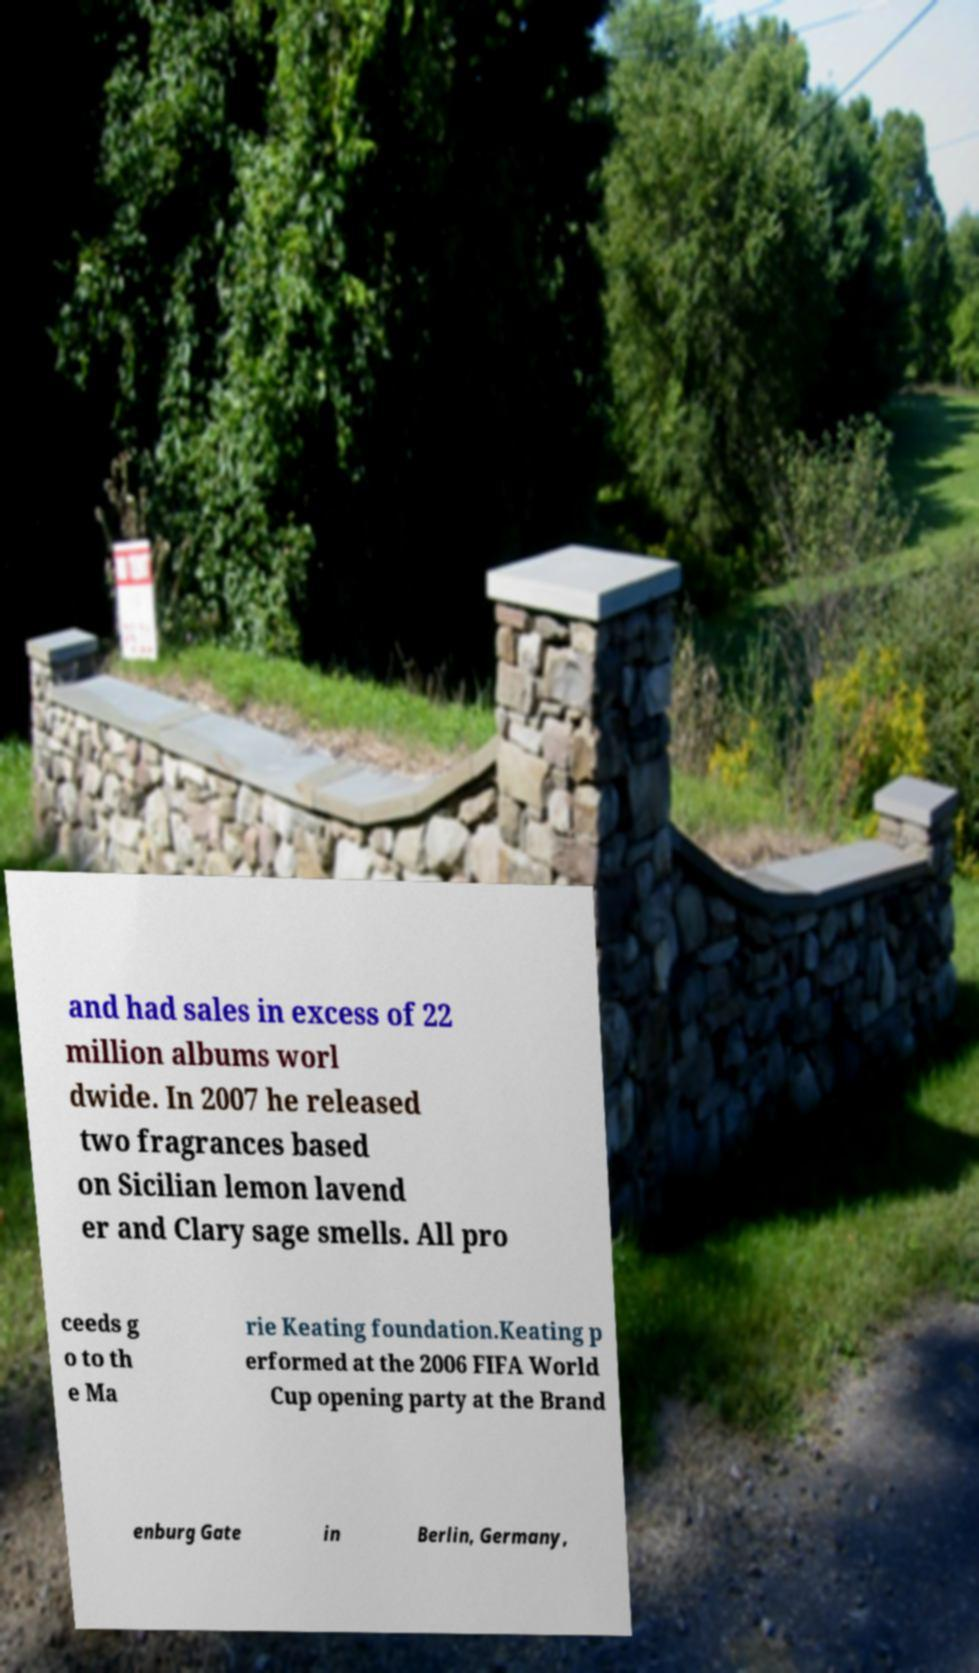I need the written content from this picture converted into text. Can you do that? and had sales in excess of 22 million albums worl dwide. In 2007 he released two fragrances based on Sicilian lemon lavend er and Clary sage smells. All pro ceeds g o to th e Ma rie Keating foundation.Keating p erformed at the 2006 FIFA World Cup opening party at the Brand enburg Gate in Berlin, Germany, 